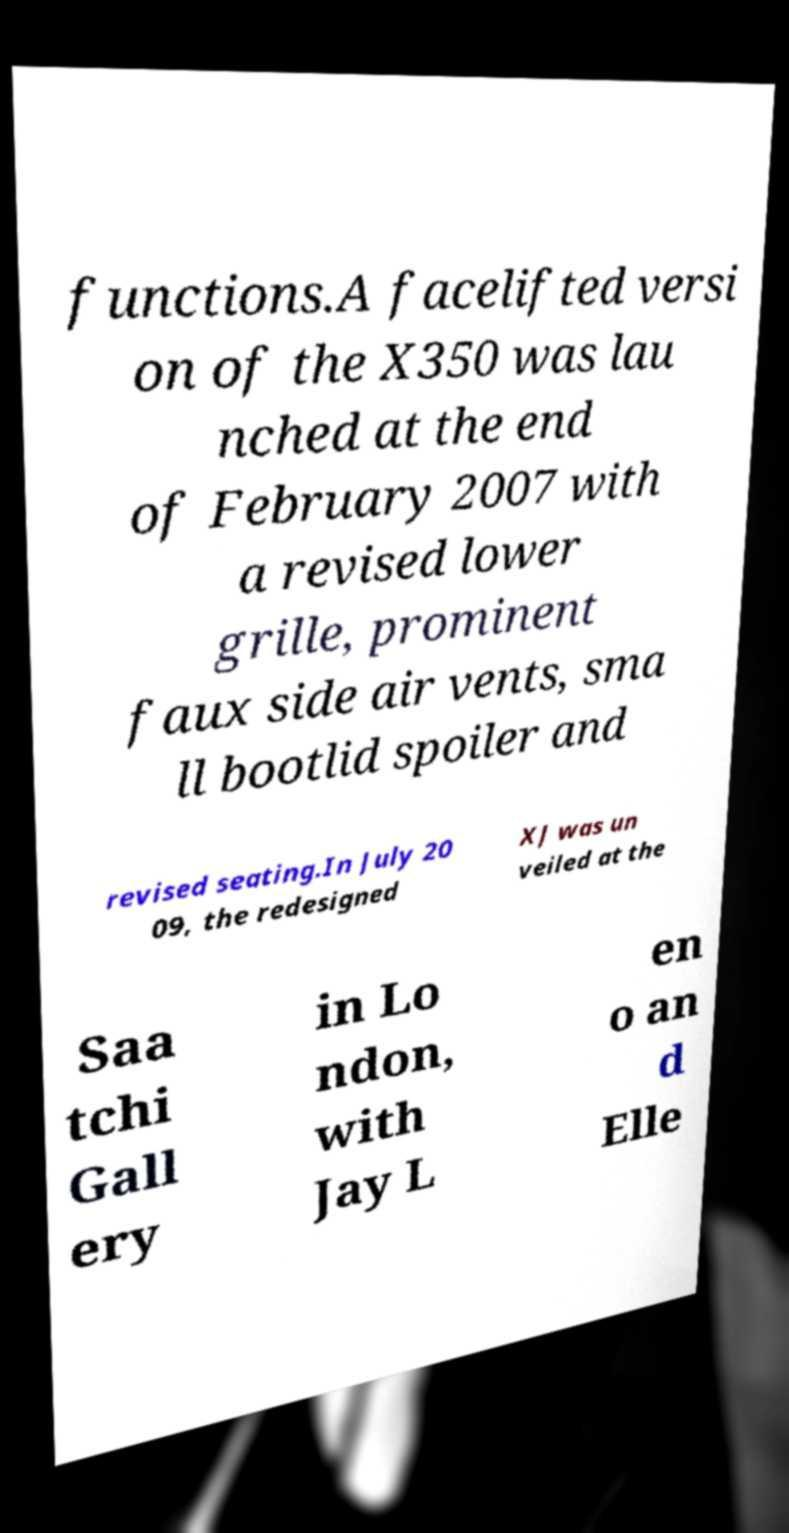For documentation purposes, I need the text within this image transcribed. Could you provide that? functions.A facelifted versi on of the X350 was lau nched at the end of February 2007 with a revised lower grille, prominent faux side air vents, sma ll bootlid spoiler and revised seating.In July 20 09, the redesigned XJ was un veiled at the Saa tchi Gall ery in Lo ndon, with Jay L en o an d Elle 